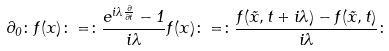<formula> <loc_0><loc_0><loc_500><loc_500>\partial _ { 0 } \colon f ( x ) \colon = \colon \frac { e ^ { i \lambda { \frac { \partial } { \partial t } } } - 1 } { i \lambda } f ( x ) \colon = \colon \frac { f ( \vec { x } , t + i \lambda ) - f ( \vec { x } , t ) } { i \lambda } \colon</formula> 